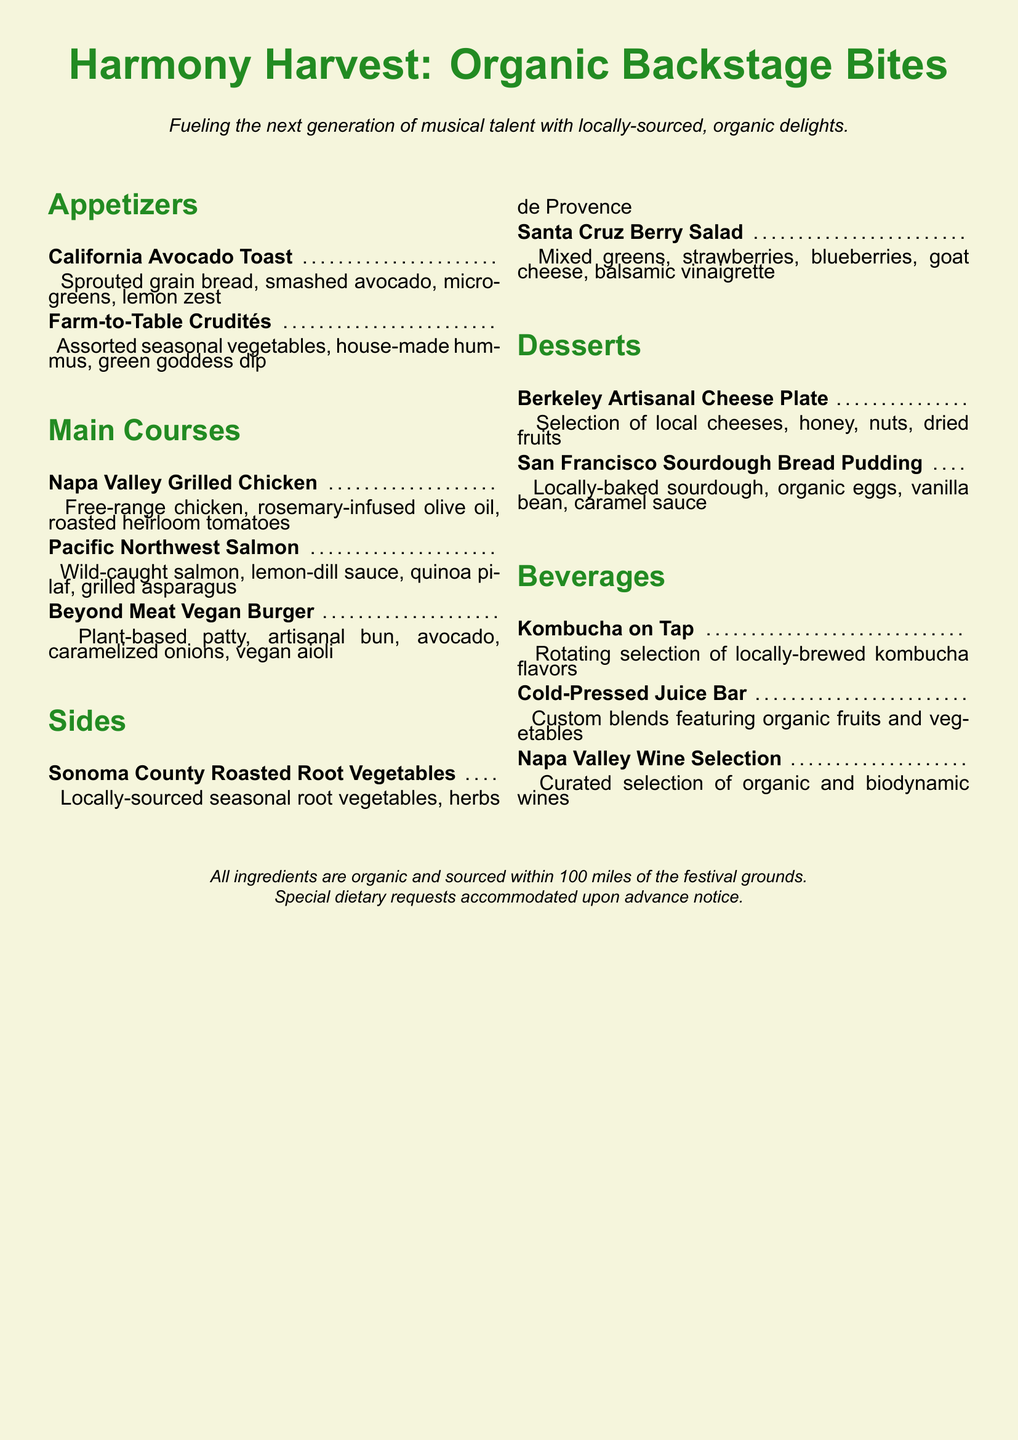What is the title of the menu? The title of the menu is prominently displayed at the top of the document.
Answer: Harmony Harvest: Organic Backstage Bites What type of bread is used in the California Avocado Toast? The specific type of bread used in the dish is mentioned in the ingredients list.
Answer: Sprouted grain bread What is the main protein in the Pacific Northwest Salmon dish? The main protein source for this dish is highlighted in the main courses section.
Answer: Wild-caught salmon What kind of salad is included in the sides? The name of the salad is specified in the sides section of the menu.
Answer: Santa Cruz Berry Salad How many appetizers are listed on the menu? By counting the appetizers in the appetizers section, we can determine the total.
Answer: 2 What beverage is available on tap? The document mentions a specific type of beverage available in the beverages section.
Answer: Kombucha on Tap What type of dietary requests can be accommodated? The type of requests that can be accommodated is mentioned in the footnote of the document.
Answer: Special dietary requests What is the main ingredient for the Beyond Meat Vegan Burger? The main ingredient in this vegan burger is stated in the description of the dish.
Answer: Plant-based patty What is included in the Berkeley Artisanal Cheese Plate? The ingredients included in this dish are listed under desserts.
Answer: Local cheeses, honey, nuts, dried fruits 